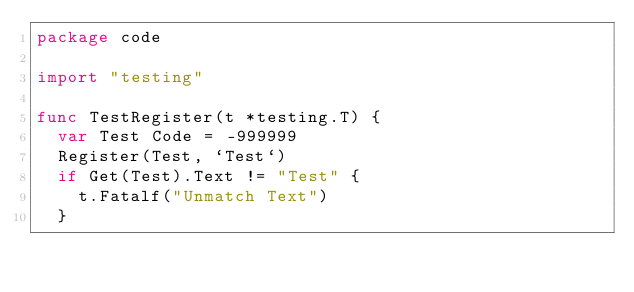<code> <loc_0><loc_0><loc_500><loc_500><_Go_>package code

import "testing"

func TestRegister(t *testing.T) {
	var Test Code = -999999
	Register(Test, `Test`)
	if Get(Test).Text != "Test" {
		t.Fatalf("Unmatch Text")
	}</code> 